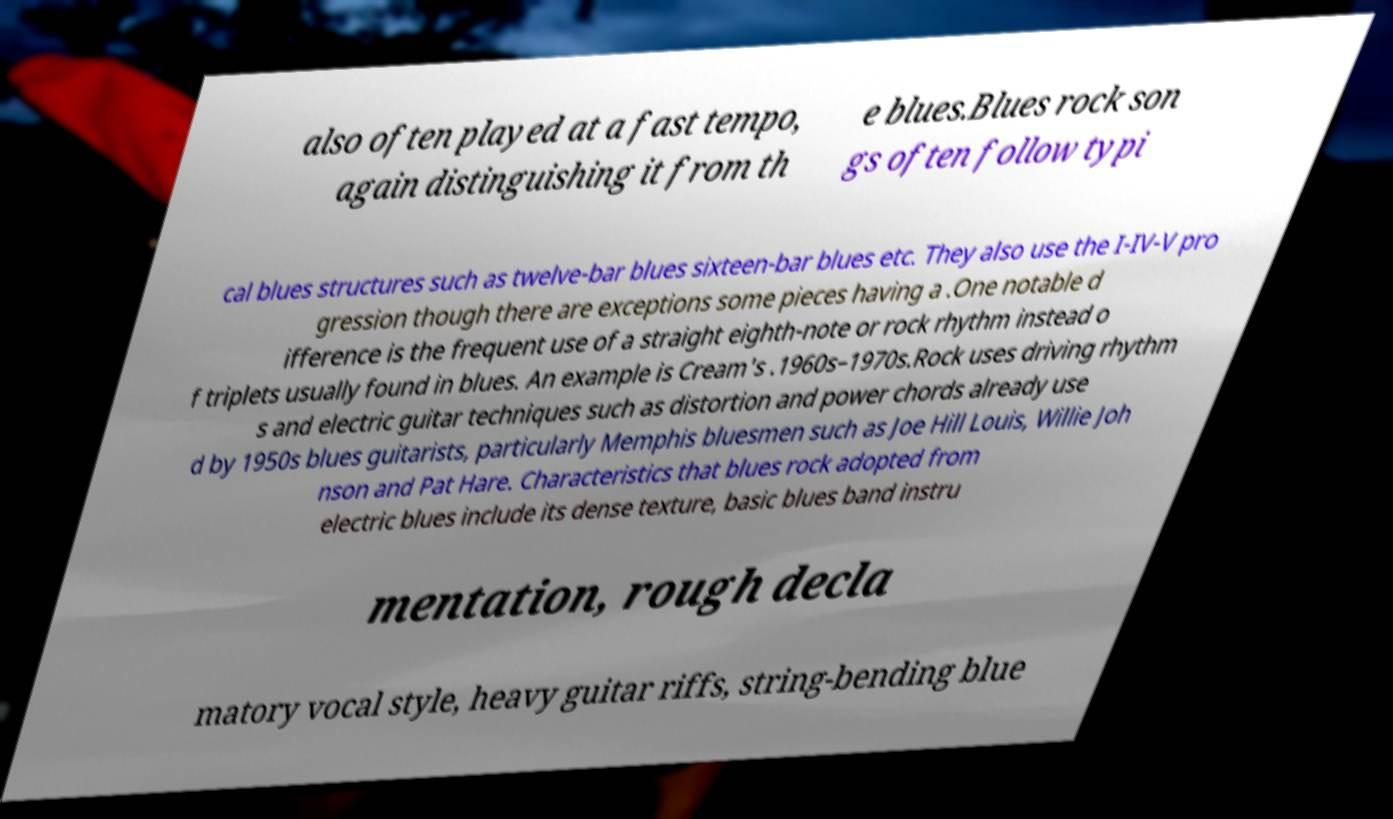Could you assist in decoding the text presented in this image and type it out clearly? also often played at a fast tempo, again distinguishing it from th e blues.Blues rock son gs often follow typi cal blues structures such as twelve-bar blues sixteen-bar blues etc. They also use the I-IV-V pro gression though there are exceptions some pieces having a .One notable d ifference is the frequent use of a straight eighth-note or rock rhythm instead o f triplets usually found in blues. An example is Cream's .1960s–1970s.Rock uses driving rhythm s and electric guitar techniques such as distortion and power chords already use d by 1950s blues guitarists, particularly Memphis bluesmen such as Joe Hill Louis, Willie Joh nson and Pat Hare. Characteristics that blues rock adopted from electric blues include its dense texture, basic blues band instru mentation, rough decla matory vocal style, heavy guitar riffs, string-bending blue 